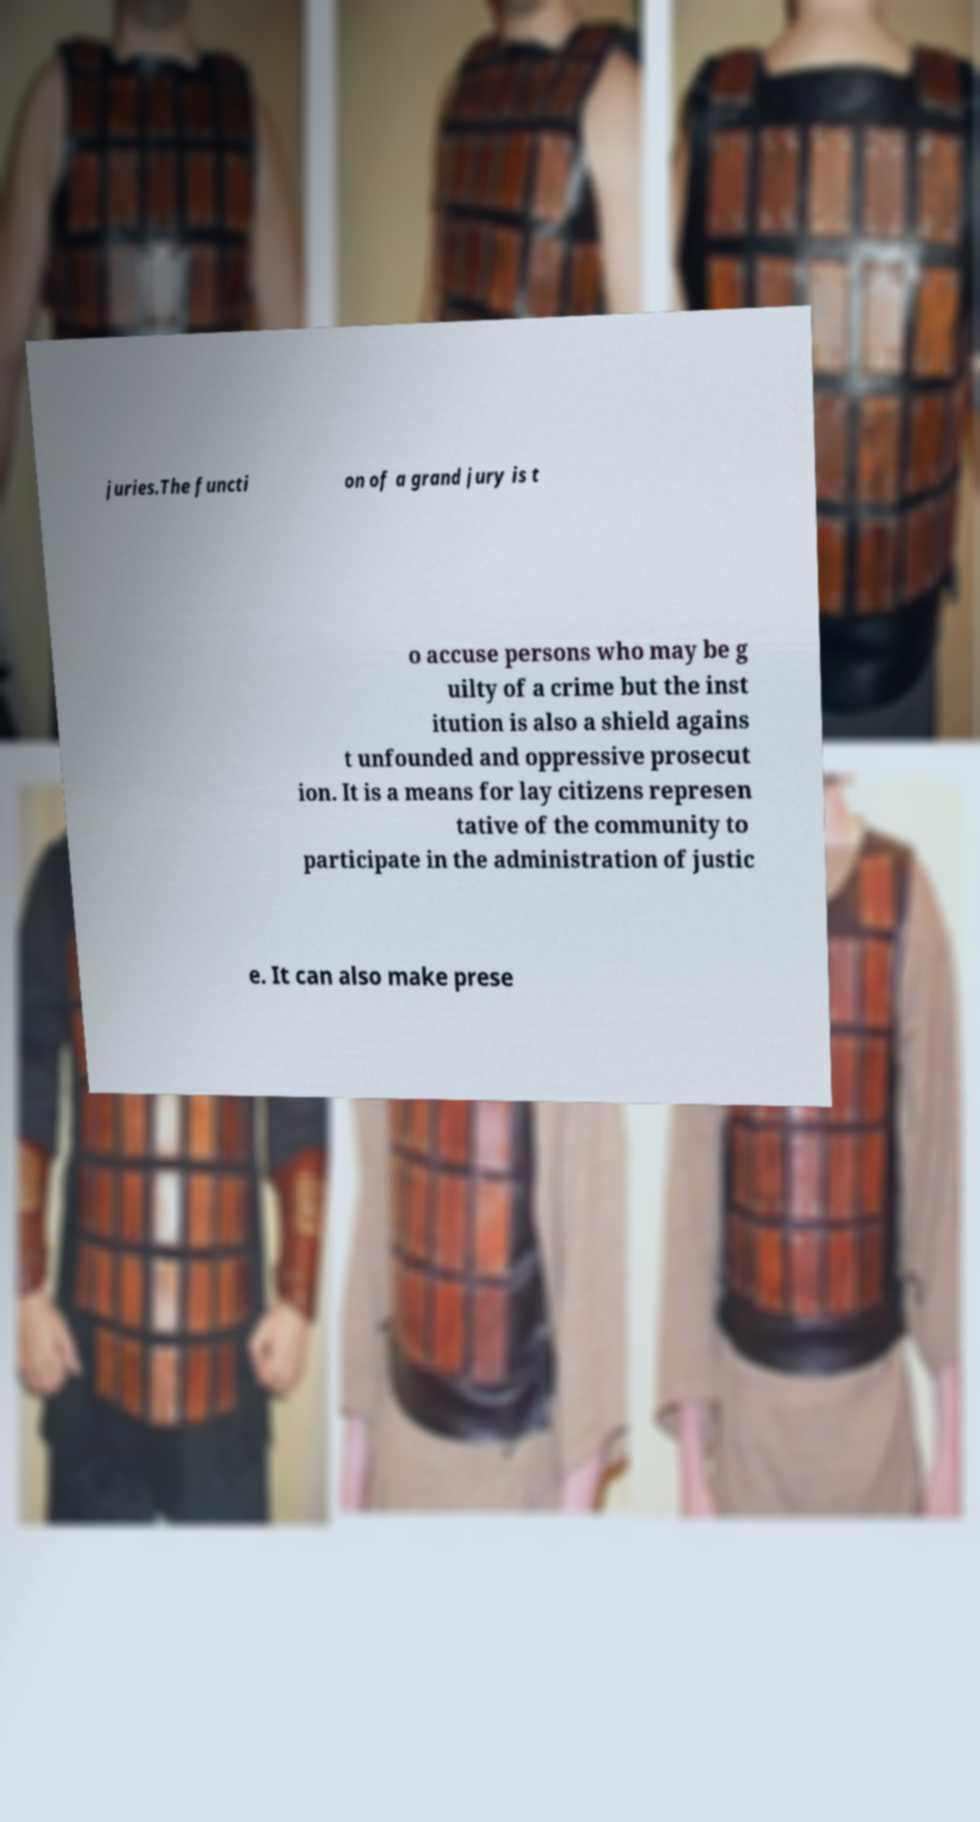For documentation purposes, I need the text within this image transcribed. Could you provide that? juries.The functi on of a grand jury is t o accuse persons who may be g uilty of a crime but the inst itution is also a shield agains t unfounded and oppressive prosecut ion. It is a means for lay citizens represen tative of the community to participate in the administration of justic e. It can also make prese 